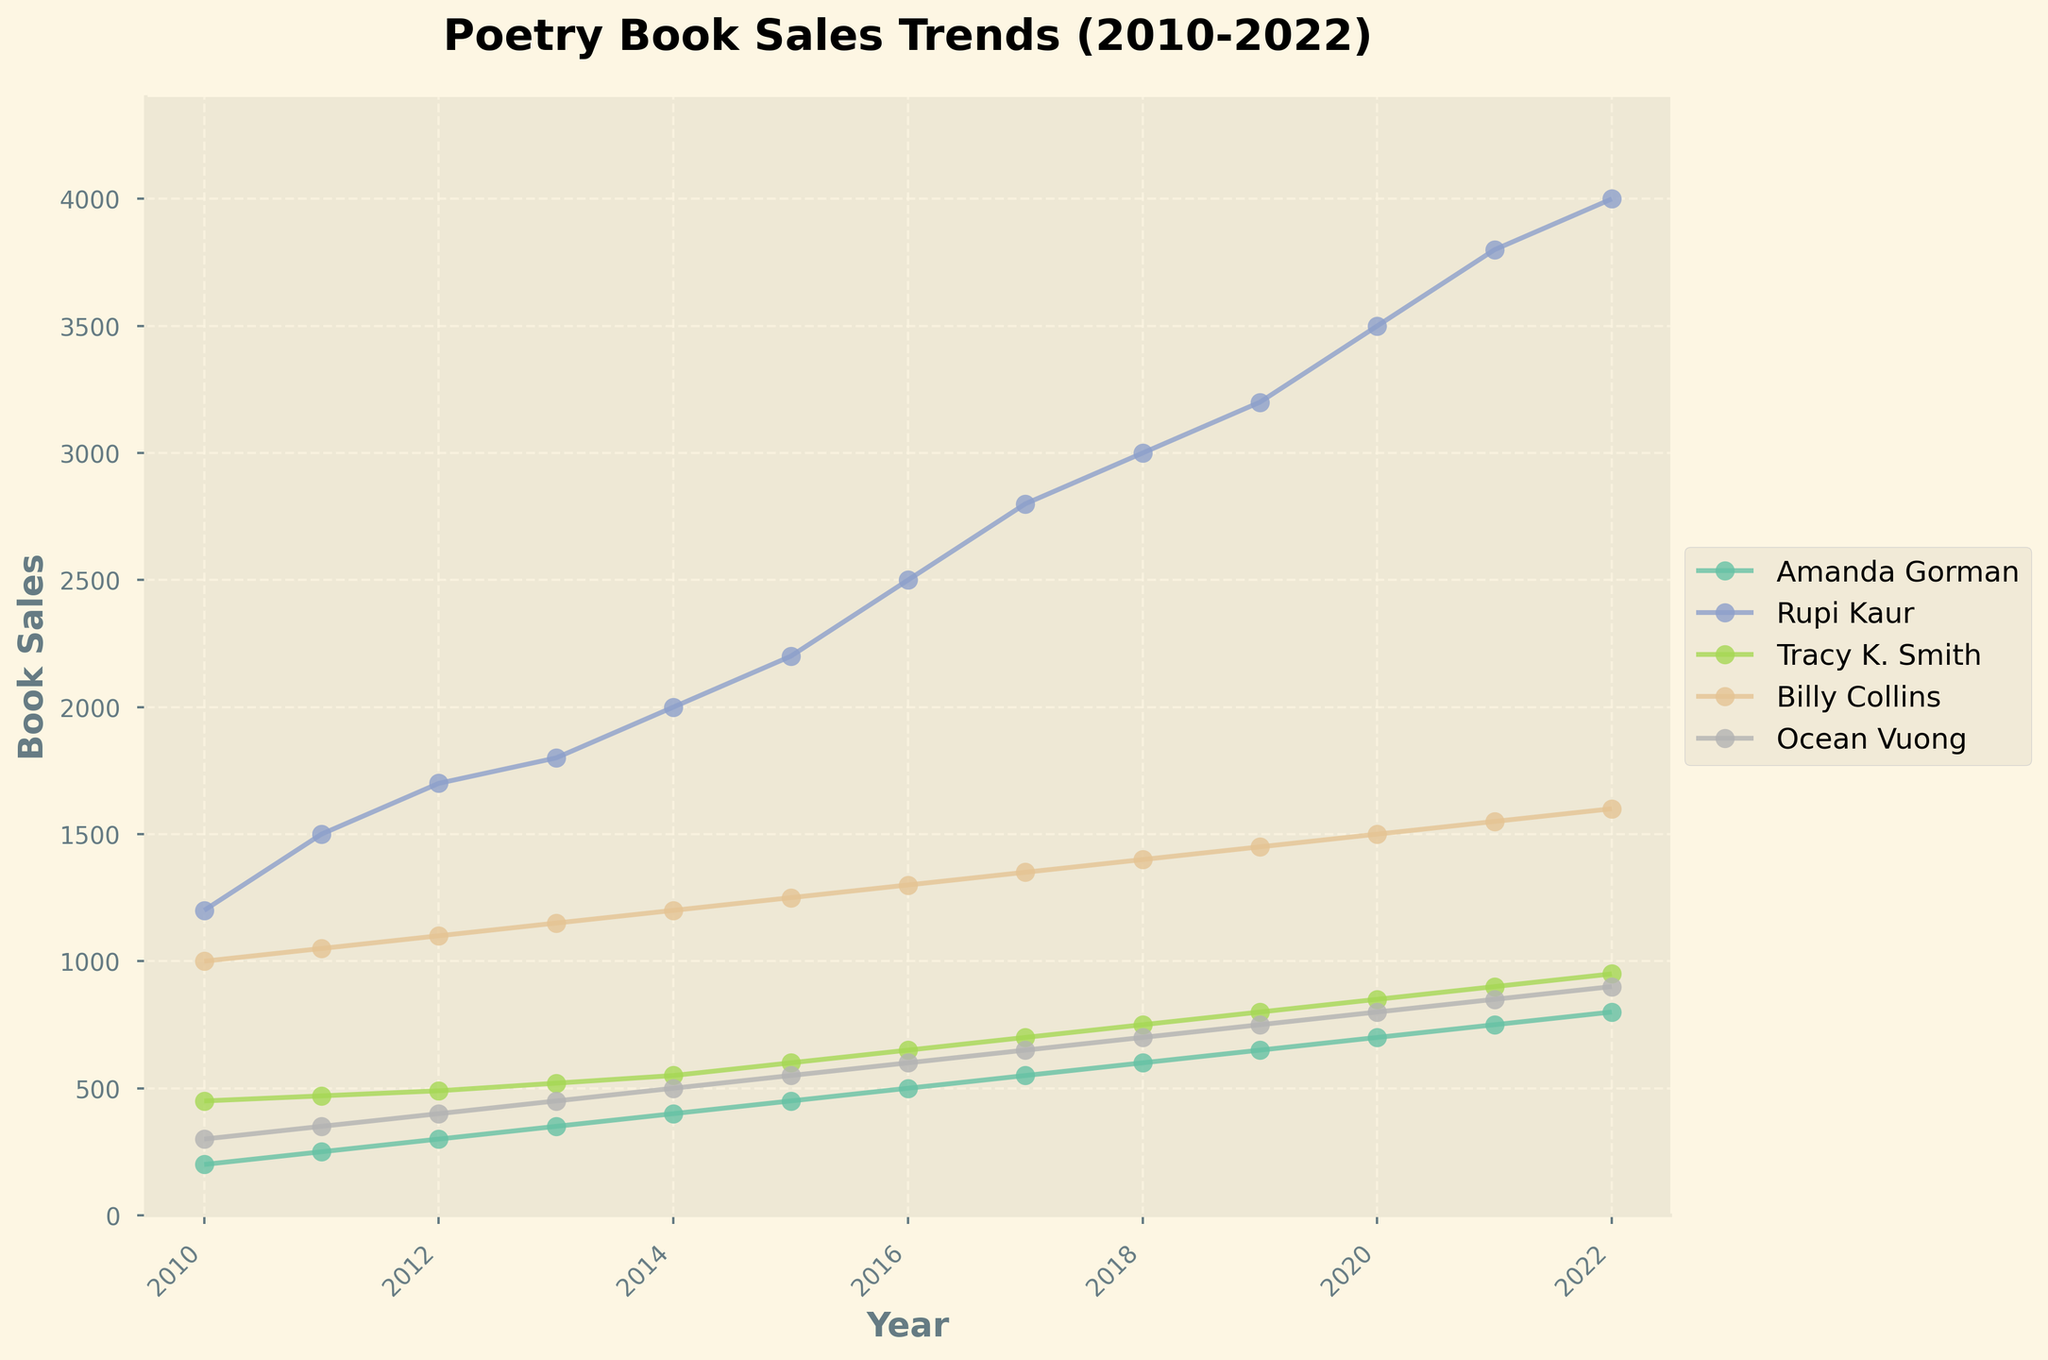How many authors are tracked in the figure? Count the distinct lines representing each author in the legend in the figure.
Answer: 5 Which author had the highest book sales in 2015? Look for the highest point in the year 2015 along the x-axis and identify the corresponding author from the legend.
Answer: Rupi Kaur What is the overall trend in book sales for Amanda Gorman from 2010 to 2022? Observe the line for Amanda Gorman and describe the general direction it follows from 2010 to 2022.
Answer: Increasing By how much did Ocean Vuong's book sales increase from 2010 to 2022? Subtract Ocean Vuong's book sales value in 2010 from his book sales value in 2022.
Answer: 600 Which two authors had steadily increasing sales over the decade? Identify the authors whose lines consistently slope upwards from 2010 to 2022.
Answer: Amanda Gorman and Ocean Vuong Who had the highest book sales in the year 2022? Look for the highest point on the far right side of the figure (2022) and identify the corresponding author.
Answer: Rupi Kaur What year did Tracy K. Smith's book sales first exceed 500 copies? Trace the line for Tracy K. Smith and find the first year where the value crosses 500 on the y-axis.
Answer: 2014 Compare Rupi Kaur's sales in 2010 and 2022. By what factor did they increase? Divide the book sales value for Rupi Kaur in 2022 by her sales value in 2010.
Answer: 3.33 What was the combined sales of all authors in 2017? Add up the book sales for each author in 2017.
Answer: 6050 Which author had the most fluctuating book sales over the decade according to the figure? Observe the trajectories of each line and identify the author with the most variance in their sales.
Answer: Billy Collins 